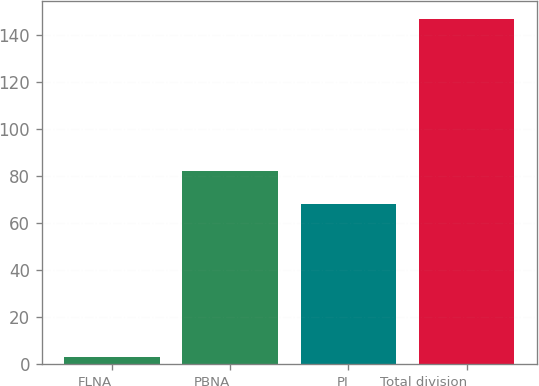Convert chart. <chart><loc_0><loc_0><loc_500><loc_500><bar_chart><fcel>FLNA<fcel>PBNA<fcel>PI<fcel>Total division<nl><fcel>3<fcel>82.4<fcel>68<fcel>147<nl></chart> 